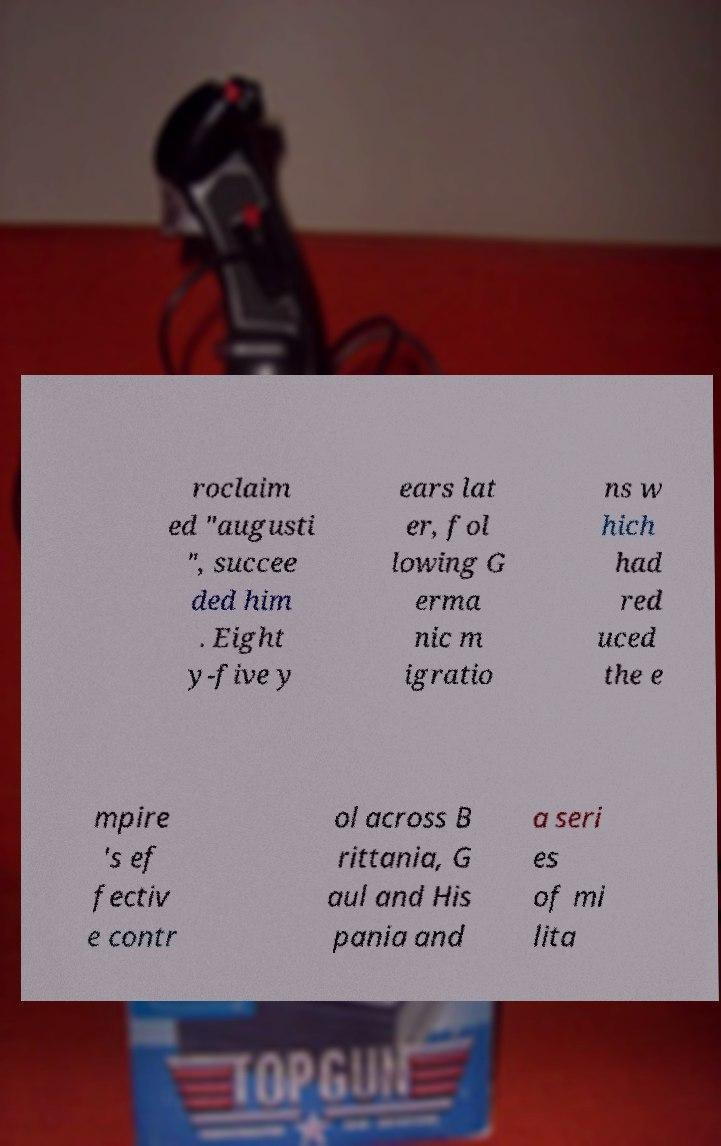Could you assist in decoding the text presented in this image and type it out clearly? roclaim ed "augusti ", succee ded him . Eight y-five y ears lat er, fol lowing G erma nic m igratio ns w hich had red uced the e mpire 's ef fectiv e contr ol across B rittania, G aul and His pania and a seri es of mi lita 